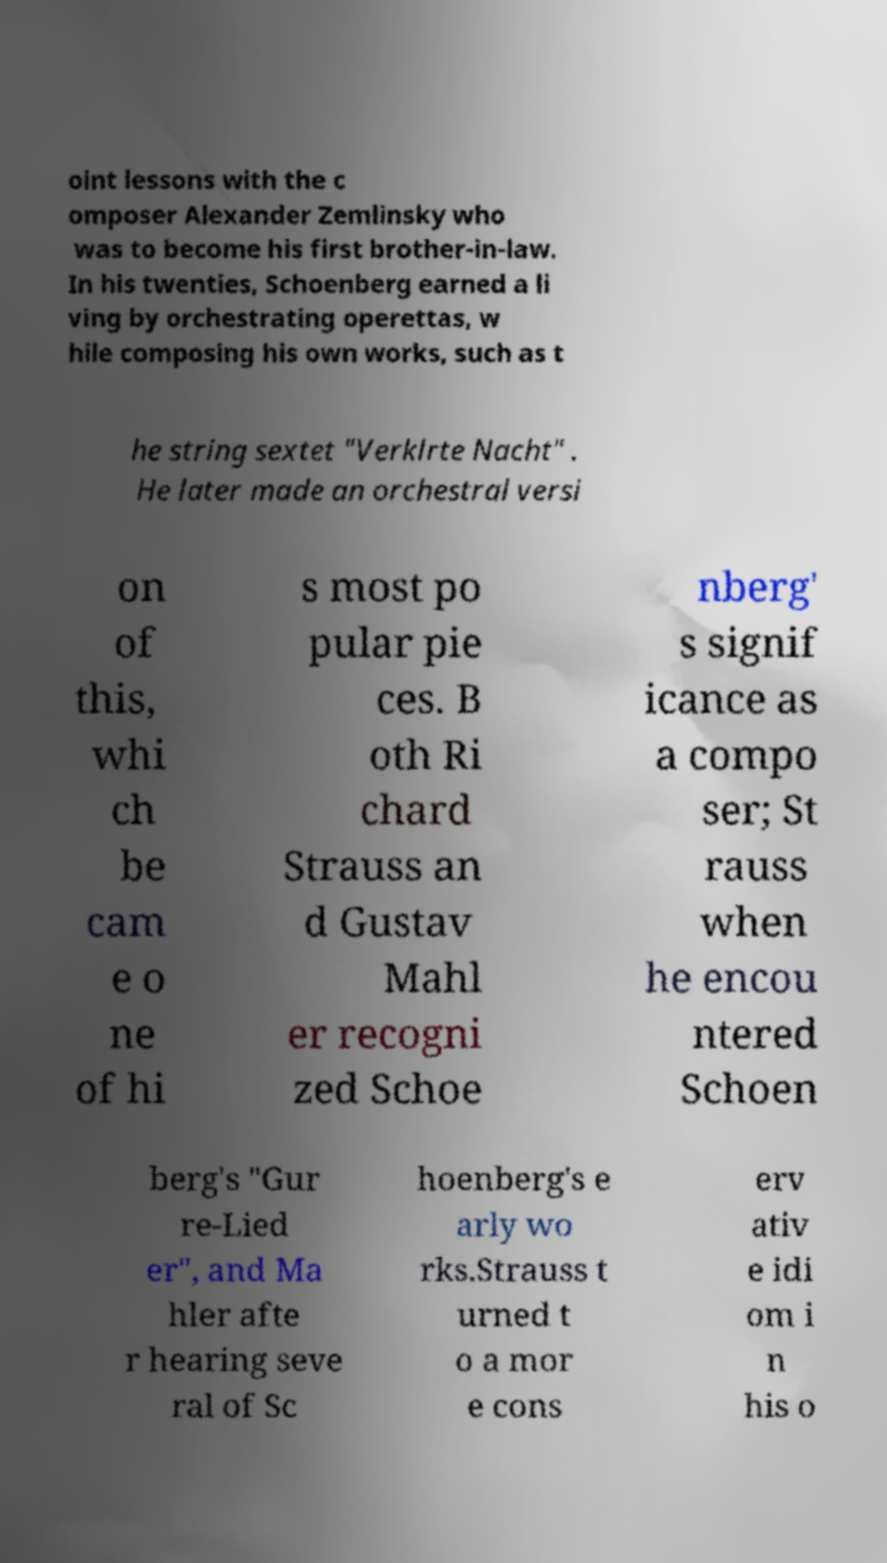There's text embedded in this image that I need extracted. Can you transcribe it verbatim? oint lessons with the c omposer Alexander Zemlinsky who was to become his first brother-in-law. In his twenties, Schoenberg earned a li ving by orchestrating operettas, w hile composing his own works, such as t he string sextet "Verklrte Nacht" . He later made an orchestral versi on of this, whi ch be cam e o ne of hi s most po pular pie ces. B oth Ri chard Strauss an d Gustav Mahl er recogni zed Schoe nberg' s signif icance as a compo ser; St rauss when he encou ntered Schoen berg's "Gur re-Lied er", and Ma hler afte r hearing seve ral of Sc hoenberg's e arly wo rks.Strauss t urned t o a mor e cons erv ativ e idi om i n his o 